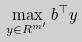Convert formula to latex. <formula><loc_0><loc_0><loc_500><loc_500>\max _ { y \in R ^ { m ^ { \prime } } } b ^ { \top } y</formula> 